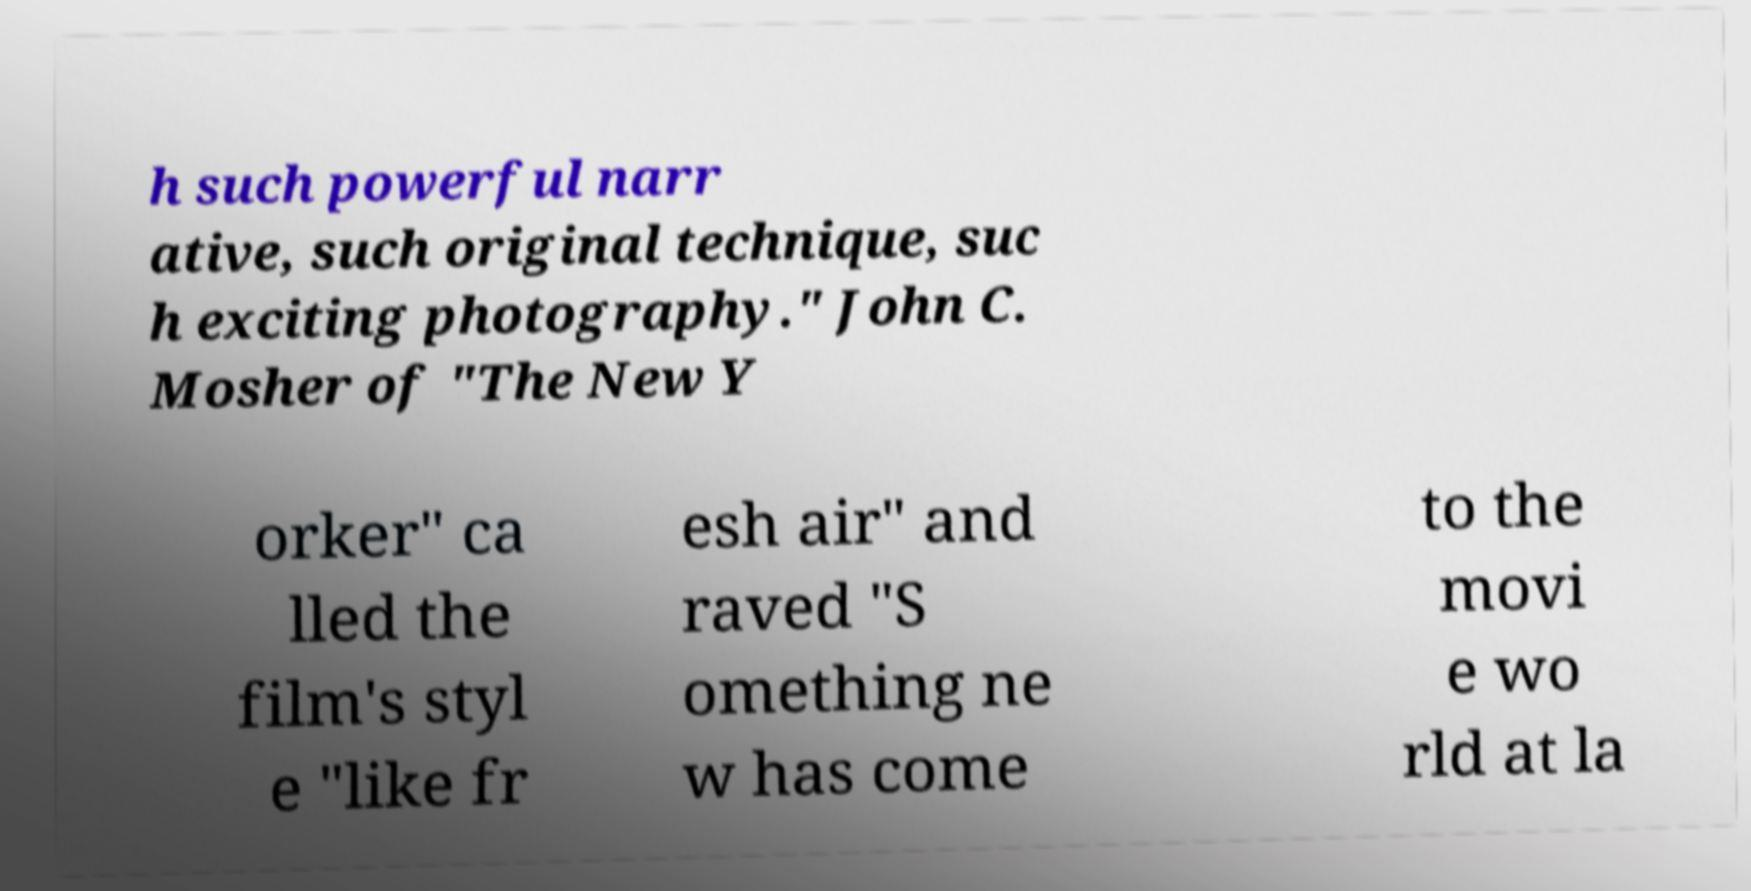Can you accurately transcribe the text from the provided image for me? h such powerful narr ative, such original technique, suc h exciting photography." John C. Mosher of "The New Y orker" ca lled the film's styl e "like fr esh air" and raved "S omething ne w has come to the movi e wo rld at la 